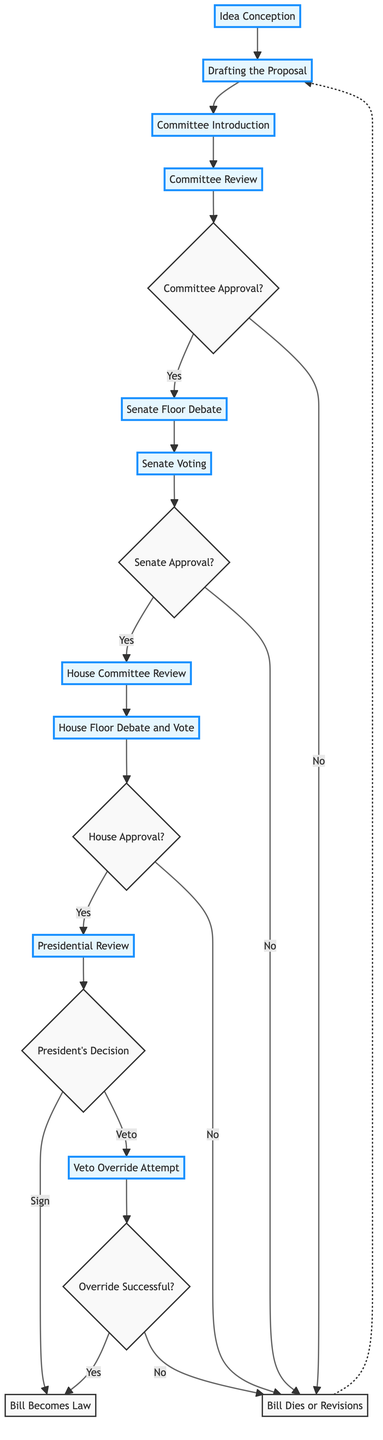What is the first stage of the legislative process? The diagram indicates that the first stage is "Idea Conception," where the initial idea for a bill is proposed by a Senator with input from various stakeholders.
Answer: Idea Conception How many stages are there in total? By counting all the distinct stages outlined in the diagram, we find there are 12 stages from "Idea Conception" to "Bill Becomes Law."
Answer: 12 What decision occurs after the Committee Review? The flowchart shows that after the Committee Review, a decision is made regarding "Committee Approval," which determines if the bill can proceed.
Answer: Committee Approval What happens if the Senate does not approve the bill? According to the diagram, if the Senate does not approve the bill, it leads back to the point where the bill either dies or requires revisions.
Answer: Bill Dies or Revisions How does a bill become law? The diagram illustrates that a bill becomes law if it is signed by the President or if Congress successfully overrides a veto.
Answer: Bill Becomes Law What is the last decision made in this process? The final decision indicated in the diagram is the "Override Successful?" for a veto override attempt after the President's veto, determining the fate of the proposed law.
Answer: Override Successful? How many possible outcomes are there after the Presidential Review? From the flowchart, after the Presidential Review, there are two possible outcomes: the bill can either be signed or vetoed, leading to distinct branches in the flow.
Answer: 2 What stage follows Senate Floor Debate? After the Senate Floor Debate stage, the flowchart shows the next step is "Senate Voting," where Senators vote on the bill.
Answer: Senate Voting What action can Congress take if the President vetoes the bill? The diagram indicates that if the President vetoes the bill, Congress has the option to attempt a "Veto Override" if they wish to proceed with the bill despite the veto.
Answer: Veto Override Attempt 